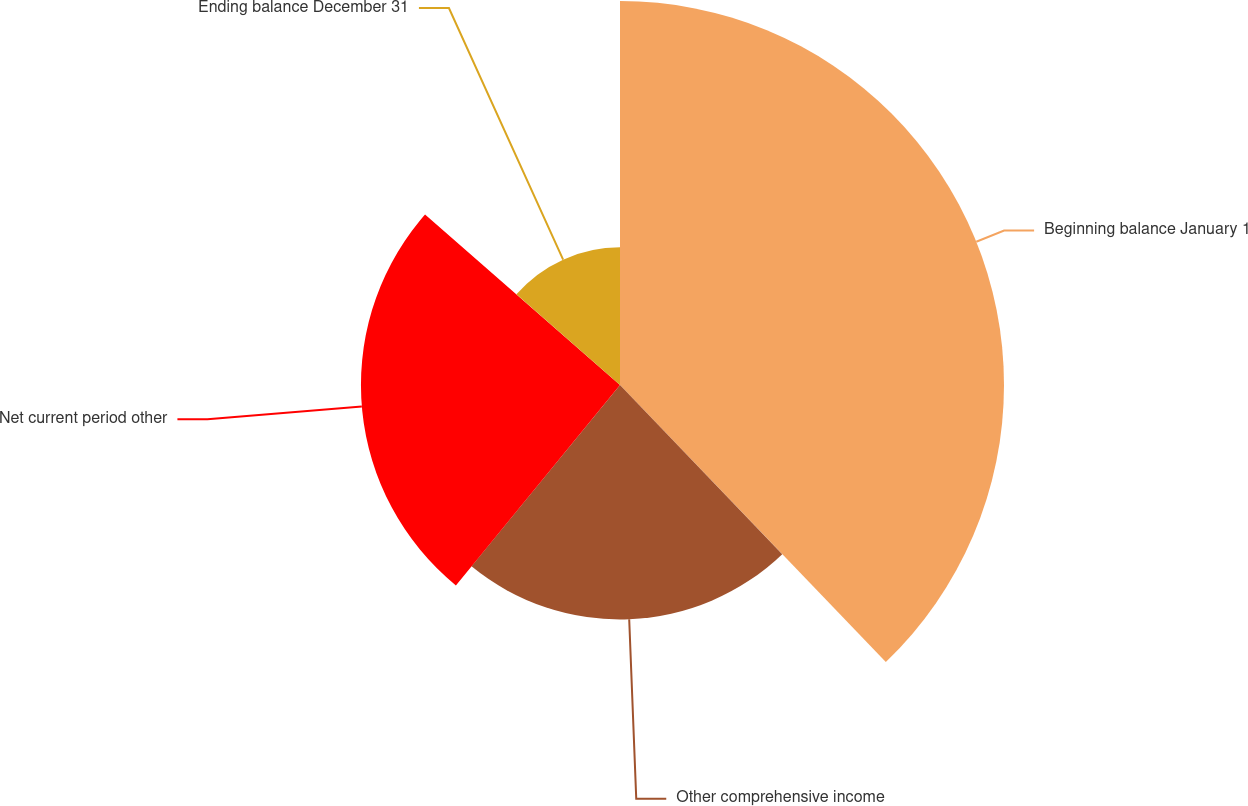Convert chart to OTSL. <chart><loc_0><loc_0><loc_500><loc_500><pie_chart><fcel>Beginning balance January 1<fcel>Other comprehensive income<fcel>Net current period other<fcel>Ending balance December 31<nl><fcel>37.83%<fcel>23.09%<fcel>25.52%<fcel>13.56%<nl></chart> 